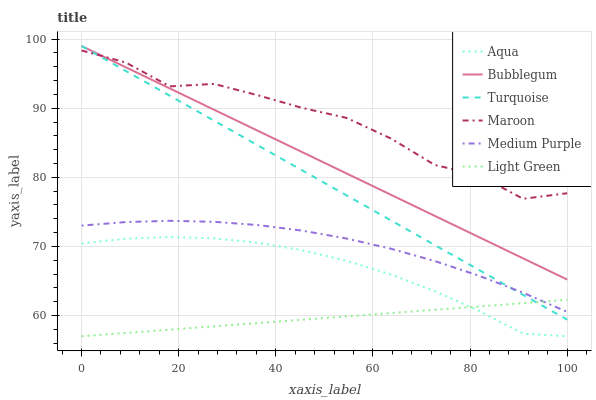Does Light Green have the minimum area under the curve?
Answer yes or no. Yes. Does Maroon have the maximum area under the curve?
Answer yes or no. Yes. Does Aqua have the minimum area under the curve?
Answer yes or no. No. Does Aqua have the maximum area under the curve?
Answer yes or no. No. Is Light Green the smoothest?
Answer yes or no. Yes. Is Maroon the roughest?
Answer yes or no. Yes. Is Aqua the smoothest?
Answer yes or no. No. Is Aqua the roughest?
Answer yes or no. No. Does Aqua have the lowest value?
Answer yes or no. Yes. Does Maroon have the lowest value?
Answer yes or no. No. Does Bubblegum have the highest value?
Answer yes or no. Yes. Does Aqua have the highest value?
Answer yes or no. No. Is Aqua less than Medium Purple?
Answer yes or no. Yes. Is Bubblegum greater than Medium Purple?
Answer yes or no. Yes. Does Turquoise intersect Maroon?
Answer yes or no. Yes. Is Turquoise less than Maroon?
Answer yes or no. No. Is Turquoise greater than Maroon?
Answer yes or no. No. Does Aqua intersect Medium Purple?
Answer yes or no. No. 